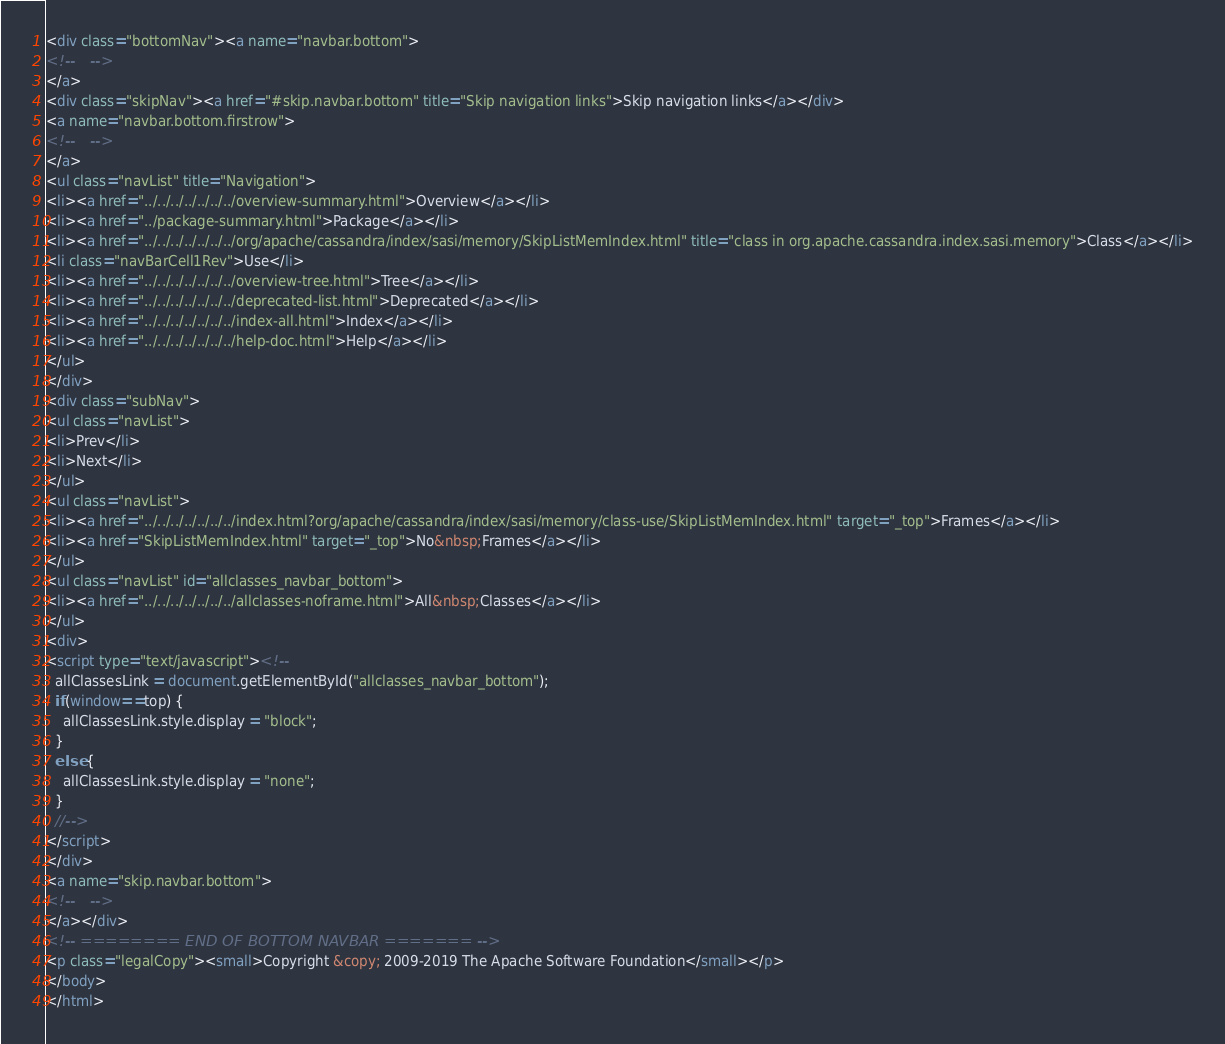Convert code to text. <code><loc_0><loc_0><loc_500><loc_500><_HTML_><div class="bottomNav"><a name="navbar.bottom">
<!--   -->
</a>
<div class="skipNav"><a href="#skip.navbar.bottom" title="Skip navigation links">Skip navigation links</a></div>
<a name="navbar.bottom.firstrow">
<!--   -->
</a>
<ul class="navList" title="Navigation">
<li><a href="../../../../../../../overview-summary.html">Overview</a></li>
<li><a href="../package-summary.html">Package</a></li>
<li><a href="../../../../../../../org/apache/cassandra/index/sasi/memory/SkipListMemIndex.html" title="class in org.apache.cassandra.index.sasi.memory">Class</a></li>
<li class="navBarCell1Rev">Use</li>
<li><a href="../../../../../../../overview-tree.html">Tree</a></li>
<li><a href="../../../../../../../deprecated-list.html">Deprecated</a></li>
<li><a href="../../../../../../../index-all.html">Index</a></li>
<li><a href="../../../../../../../help-doc.html">Help</a></li>
</ul>
</div>
<div class="subNav">
<ul class="navList">
<li>Prev</li>
<li>Next</li>
</ul>
<ul class="navList">
<li><a href="../../../../../../../index.html?org/apache/cassandra/index/sasi/memory/class-use/SkipListMemIndex.html" target="_top">Frames</a></li>
<li><a href="SkipListMemIndex.html" target="_top">No&nbsp;Frames</a></li>
</ul>
<ul class="navList" id="allclasses_navbar_bottom">
<li><a href="../../../../../../../allclasses-noframe.html">All&nbsp;Classes</a></li>
</ul>
<div>
<script type="text/javascript"><!--
  allClassesLink = document.getElementById("allclasses_navbar_bottom");
  if(window==top) {
    allClassesLink.style.display = "block";
  }
  else {
    allClassesLink.style.display = "none";
  }
  //-->
</script>
</div>
<a name="skip.navbar.bottom">
<!--   -->
</a></div>
<!-- ======== END OF BOTTOM NAVBAR ======= -->
<p class="legalCopy"><small>Copyright &copy; 2009-2019 The Apache Software Foundation</small></p>
</body>
</html>
</code> 